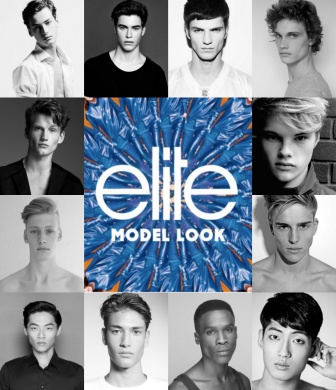Describe a day in the life of one of these models during the Elite Model Look competition. A day in the life of one of these models during the Elite Model Look competition begins early, with a wake-up call just as the sun peeks over the horizon. They head to a fitness session designed to energize and prepare them for the day's challenges. After a nourishing breakfast, they participate in a series of workshops and rehearsals, honing their catwalk skills, posing techniques, and learning to express their unique styles.

The afternoon is filled with photo shoots, where the models work with top photographers to capture the perfect shot, showcasing their adaptability and confidence. They then attend fittings for upcoming runway shows, trying on avant-garde designs that push the boundaries of fashion. As evening approaches, they gather for a seminar with industry experts who share insights and experiences about the modeling world.

The day concludes with a glamorous mock runway show, where the models get a taste of the exhilarating atmosphere of a live audience. Back in their rooms, they reflect on their progress, bond with fellow contestants, and prepare mentally for the next day, knowing that each moment brings them closer to their dreams in the modeling world. 